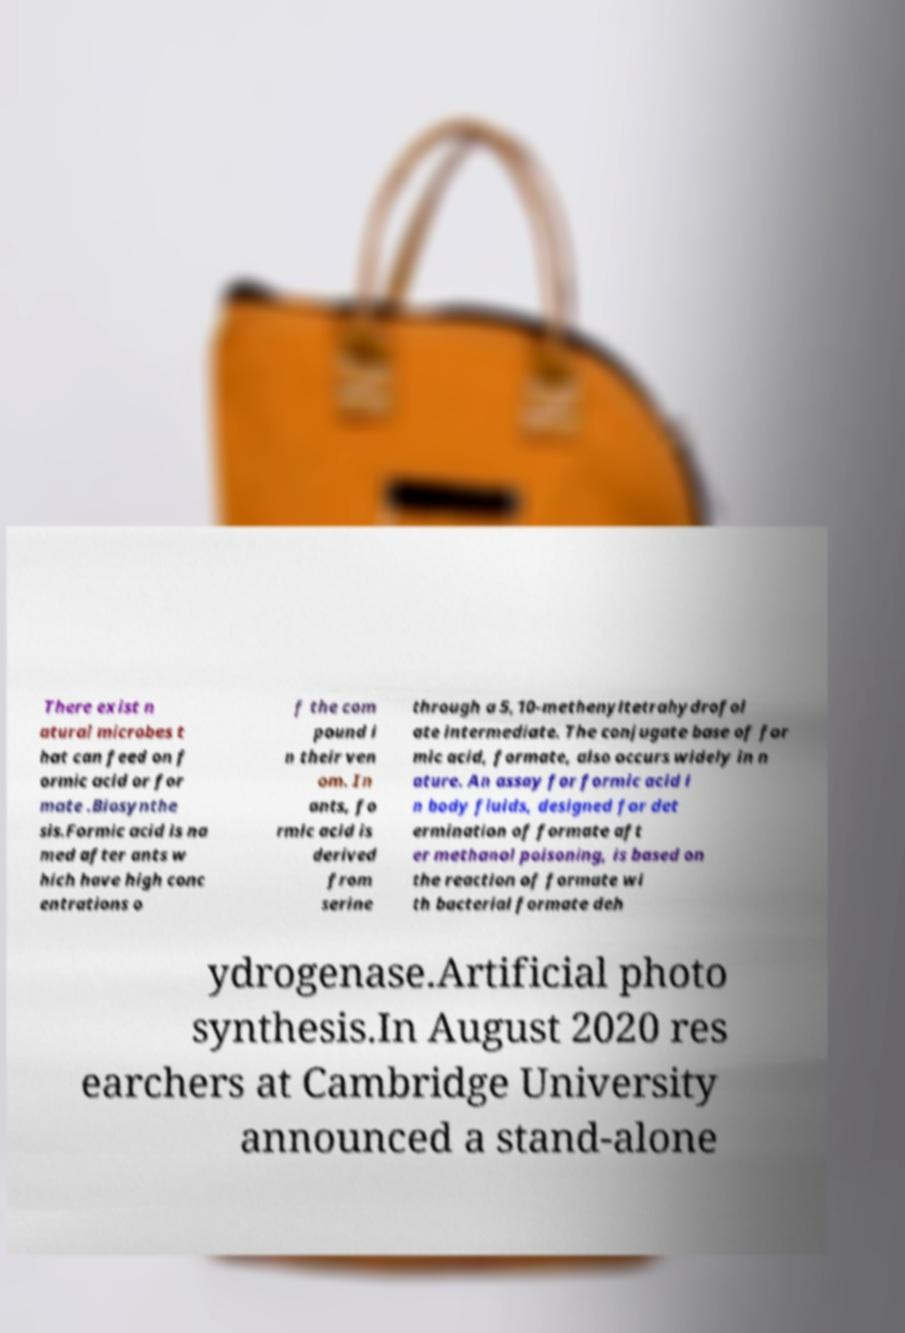Please read and relay the text visible in this image. What does it say? There exist n atural microbes t hat can feed on f ormic acid or for mate .Biosynthe sis.Formic acid is na med after ants w hich have high conc entrations o f the com pound i n their ven om. In ants, fo rmic acid is derived from serine through a 5,10-methenyltetrahydrofol ate intermediate. The conjugate base of for mic acid, formate, also occurs widely in n ature. An assay for formic acid i n body fluids, designed for det ermination of formate aft er methanol poisoning, is based on the reaction of formate wi th bacterial formate deh ydrogenase.Artificial photo synthesis.In August 2020 res earchers at Cambridge University announced a stand-alone 